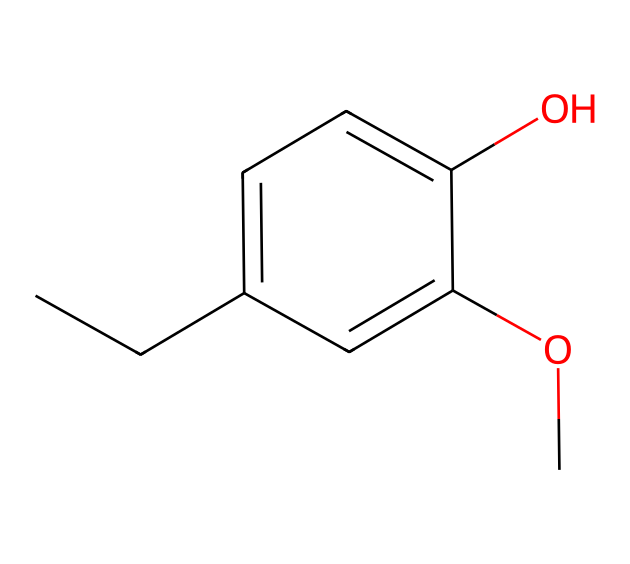What is the molecular formula of eugenol? The molecular formula can be derived by counting the types and numbers of atoms in the structure represented by the SMILES notation. In this case, there are 10 carbon atoms, 12 hydrogen atoms, and 2 oxygen atoms, generating the formula C10H12O2.
Answer: C10H12O2 How many aromatic rings are present in the structure? By analyzing the structure, one can determine that there is one distinct aromatic ring indicated by the presence of a hexagonal arrangement of carbon atoms with alternating double bonds common in aromatic compounds.
Answer: 1 What functional groups are present in eugenol? The functional groups in the chemical can be identified through the specific arrangements of atoms seen in the structure. In this case, there is a hydroxyl group (–OH) and a methoxy group (–OCH3) present in the structure, which are the functional groups in eugenol.
Answer: hydroxyl and methoxy Is eugenol a polar or nonpolar compound? To assess the polarity, we consider the presence of polar groups and the overall structure. Eugenol contains a hydroxyl group which contributes to its polarity, indicating that eugenol is relatively polar despite having a hydrophobic aromatic ring.
Answer: polar Why is eugenol effective for dental pain relief? Eugenol is effective for dental pain due to its analgesic and anti-inflammatory properties, which are a result of the molecular structure, particularly influenced by the existence of the aromatic ring and functional groups that interact with pain receptors.
Answer: analgesic and anti-inflammatory properties What type of isomerism can eugenol exhibit? The presence of different functional groups and the arrangement of atoms within the compound allow for structural isomerism, while the positions of double bonds can also exhibit geometric isomerism. The specific arrangement leads to eugenol possibly having structural isomers.
Answer: structural isomerism 